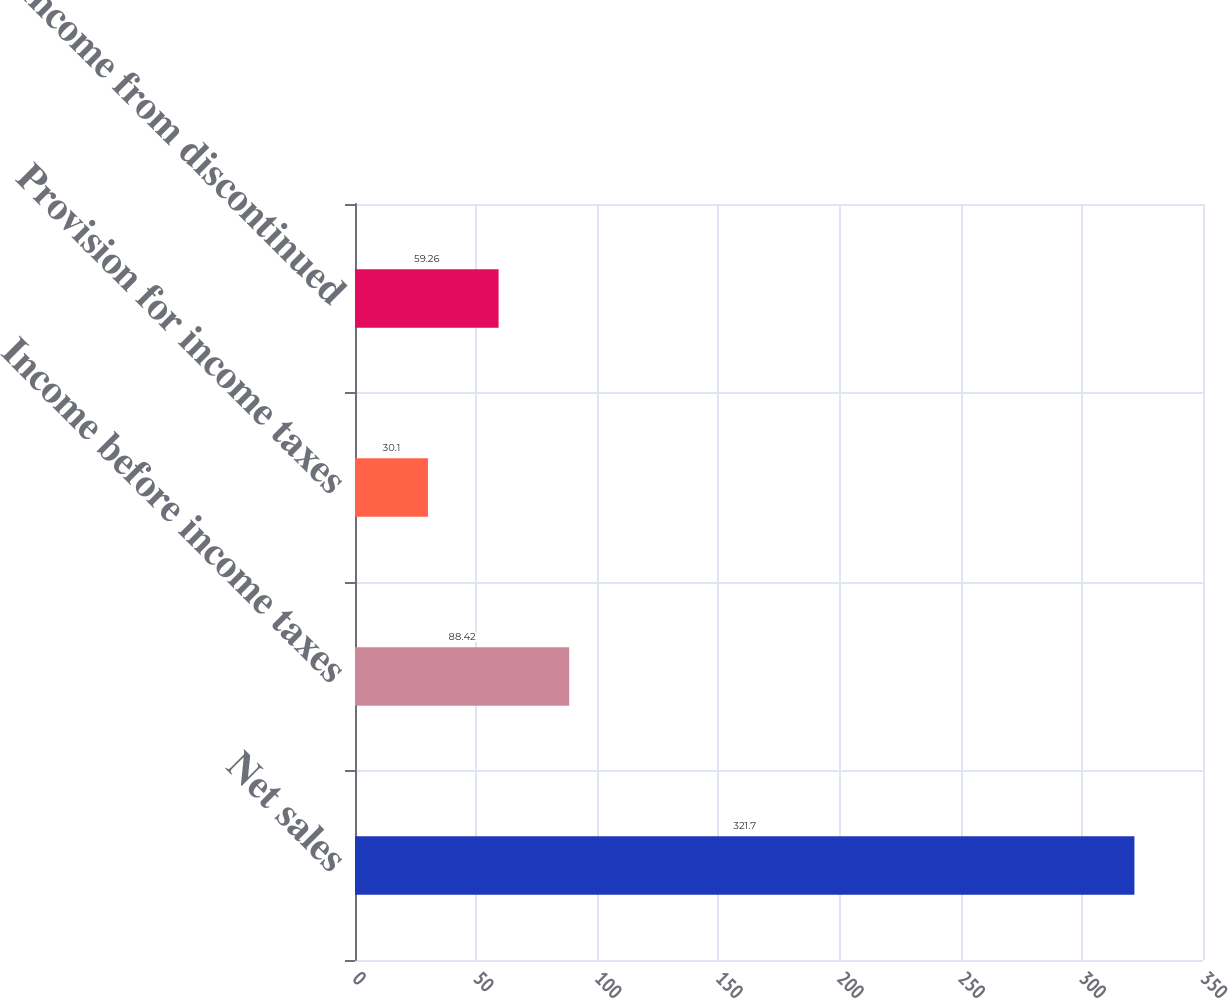Convert chart to OTSL. <chart><loc_0><loc_0><loc_500><loc_500><bar_chart><fcel>Net sales<fcel>Income before income taxes<fcel>Provision for income taxes<fcel>Income from discontinued<nl><fcel>321.7<fcel>88.42<fcel>30.1<fcel>59.26<nl></chart> 